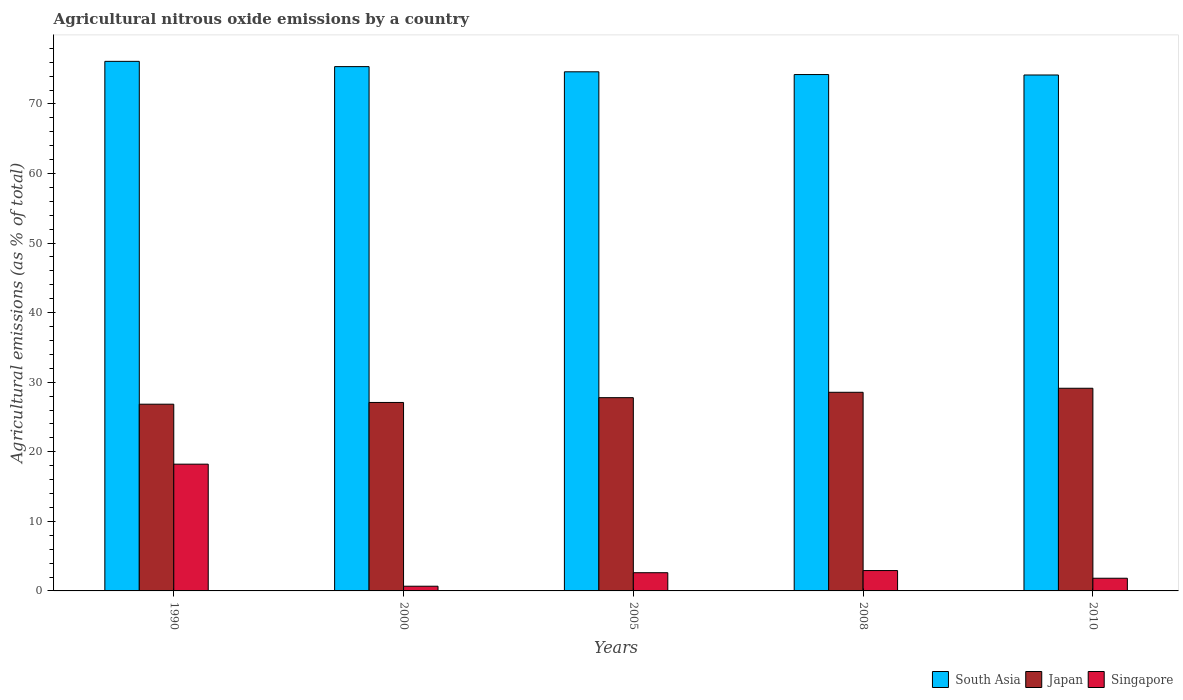How many different coloured bars are there?
Make the answer very short. 3. How many groups of bars are there?
Your response must be concise. 5. Are the number of bars per tick equal to the number of legend labels?
Offer a very short reply. Yes. Are the number of bars on each tick of the X-axis equal?
Your response must be concise. Yes. How many bars are there on the 3rd tick from the left?
Ensure brevity in your answer.  3. How many bars are there on the 4th tick from the right?
Keep it short and to the point. 3. What is the amount of agricultural nitrous oxide emitted in South Asia in 2005?
Make the answer very short. 74.62. Across all years, what is the maximum amount of agricultural nitrous oxide emitted in Singapore?
Offer a terse response. 18.22. Across all years, what is the minimum amount of agricultural nitrous oxide emitted in Japan?
Offer a terse response. 26.84. In which year was the amount of agricultural nitrous oxide emitted in Japan maximum?
Keep it short and to the point. 2010. What is the total amount of agricultural nitrous oxide emitted in Japan in the graph?
Ensure brevity in your answer.  139.39. What is the difference between the amount of agricultural nitrous oxide emitted in Singapore in 2005 and that in 2008?
Provide a short and direct response. -0.31. What is the difference between the amount of agricultural nitrous oxide emitted in Singapore in 2008 and the amount of agricultural nitrous oxide emitted in Japan in 2010?
Your answer should be very brief. -26.2. What is the average amount of agricultural nitrous oxide emitted in Japan per year?
Provide a succinct answer. 27.88. In the year 2008, what is the difference between the amount of agricultural nitrous oxide emitted in Japan and amount of agricultural nitrous oxide emitted in South Asia?
Your response must be concise. -45.67. In how many years, is the amount of agricultural nitrous oxide emitted in Japan greater than 56 %?
Offer a terse response. 0. What is the ratio of the amount of agricultural nitrous oxide emitted in Japan in 2000 to that in 2005?
Offer a terse response. 0.98. Is the difference between the amount of agricultural nitrous oxide emitted in Japan in 1990 and 2010 greater than the difference between the amount of agricultural nitrous oxide emitted in South Asia in 1990 and 2010?
Ensure brevity in your answer.  No. What is the difference between the highest and the second highest amount of agricultural nitrous oxide emitted in South Asia?
Your response must be concise. 0.76. What is the difference between the highest and the lowest amount of agricultural nitrous oxide emitted in Japan?
Offer a terse response. 2.29. Is the sum of the amount of agricultural nitrous oxide emitted in Japan in 1990 and 2005 greater than the maximum amount of agricultural nitrous oxide emitted in Singapore across all years?
Keep it short and to the point. Yes. What does the 3rd bar from the left in 1990 represents?
Your answer should be compact. Singapore. What does the 2nd bar from the right in 2010 represents?
Keep it short and to the point. Japan. Are the values on the major ticks of Y-axis written in scientific E-notation?
Your response must be concise. No. Where does the legend appear in the graph?
Offer a terse response. Bottom right. How many legend labels are there?
Ensure brevity in your answer.  3. What is the title of the graph?
Keep it short and to the point. Agricultural nitrous oxide emissions by a country. What is the label or title of the X-axis?
Provide a succinct answer. Years. What is the label or title of the Y-axis?
Provide a short and direct response. Agricultural emissions (as % of total). What is the Agricultural emissions (as % of total) of South Asia in 1990?
Provide a succinct answer. 76.12. What is the Agricultural emissions (as % of total) in Japan in 1990?
Ensure brevity in your answer.  26.84. What is the Agricultural emissions (as % of total) of Singapore in 1990?
Offer a terse response. 18.22. What is the Agricultural emissions (as % of total) in South Asia in 2000?
Your answer should be very brief. 75.36. What is the Agricultural emissions (as % of total) of Japan in 2000?
Give a very brief answer. 27.09. What is the Agricultural emissions (as % of total) in Singapore in 2000?
Provide a succinct answer. 0.67. What is the Agricultural emissions (as % of total) in South Asia in 2005?
Offer a terse response. 74.62. What is the Agricultural emissions (as % of total) of Japan in 2005?
Provide a succinct answer. 27.78. What is the Agricultural emissions (as % of total) of Singapore in 2005?
Your response must be concise. 2.62. What is the Agricultural emissions (as % of total) of South Asia in 2008?
Ensure brevity in your answer.  74.22. What is the Agricultural emissions (as % of total) in Japan in 2008?
Provide a succinct answer. 28.55. What is the Agricultural emissions (as % of total) of Singapore in 2008?
Offer a terse response. 2.93. What is the Agricultural emissions (as % of total) in South Asia in 2010?
Make the answer very short. 74.16. What is the Agricultural emissions (as % of total) in Japan in 2010?
Provide a short and direct response. 29.13. What is the Agricultural emissions (as % of total) of Singapore in 2010?
Your answer should be compact. 1.82. Across all years, what is the maximum Agricultural emissions (as % of total) in South Asia?
Provide a short and direct response. 76.12. Across all years, what is the maximum Agricultural emissions (as % of total) of Japan?
Offer a terse response. 29.13. Across all years, what is the maximum Agricultural emissions (as % of total) in Singapore?
Keep it short and to the point. 18.22. Across all years, what is the minimum Agricultural emissions (as % of total) of South Asia?
Make the answer very short. 74.16. Across all years, what is the minimum Agricultural emissions (as % of total) of Japan?
Offer a very short reply. 26.84. Across all years, what is the minimum Agricultural emissions (as % of total) of Singapore?
Offer a very short reply. 0.67. What is the total Agricultural emissions (as % of total) in South Asia in the graph?
Ensure brevity in your answer.  374.48. What is the total Agricultural emissions (as % of total) in Japan in the graph?
Provide a succinct answer. 139.39. What is the total Agricultural emissions (as % of total) of Singapore in the graph?
Ensure brevity in your answer.  26.26. What is the difference between the Agricultural emissions (as % of total) of South Asia in 1990 and that in 2000?
Make the answer very short. 0.76. What is the difference between the Agricultural emissions (as % of total) of Japan in 1990 and that in 2000?
Ensure brevity in your answer.  -0.25. What is the difference between the Agricultural emissions (as % of total) of Singapore in 1990 and that in 2000?
Offer a terse response. 17.55. What is the difference between the Agricultural emissions (as % of total) of South Asia in 1990 and that in 2005?
Offer a terse response. 1.5. What is the difference between the Agricultural emissions (as % of total) of Japan in 1990 and that in 2005?
Offer a terse response. -0.94. What is the difference between the Agricultural emissions (as % of total) of Singapore in 1990 and that in 2005?
Provide a short and direct response. 15.6. What is the difference between the Agricultural emissions (as % of total) in South Asia in 1990 and that in 2008?
Ensure brevity in your answer.  1.9. What is the difference between the Agricultural emissions (as % of total) in Japan in 1990 and that in 2008?
Ensure brevity in your answer.  -1.71. What is the difference between the Agricultural emissions (as % of total) in Singapore in 1990 and that in 2008?
Your answer should be compact. 15.29. What is the difference between the Agricultural emissions (as % of total) of South Asia in 1990 and that in 2010?
Offer a very short reply. 1.96. What is the difference between the Agricultural emissions (as % of total) of Japan in 1990 and that in 2010?
Make the answer very short. -2.29. What is the difference between the Agricultural emissions (as % of total) in Singapore in 1990 and that in 2010?
Provide a short and direct response. 16.4. What is the difference between the Agricultural emissions (as % of total) in South Asia in 2000 and that in 2005?
Provide a succinct answer. 0.75. What is the difference between the Agricultural emissions (as % of total) of Japan in 2000 and that in 2005?
Offer a very short reply. -0.69. What is the difference between the Agricultural emissions (as % of total) of Singapore in 2000 and that in 2005?
Your response must be concise. -1.94. What is the difference between the Agricultural emissions (as % of total) of South Asia in 2000 and that in 2008?
Offer a very short reply. 1.14. What is the difference between the Agricultural emissions (as % of total) of Japan in 2000 and that in 2008?
Keep it short and to the point. -1.46. What is the difference between the Agricultural emissions (as % of total) of Singapore in 2000 and that in 2008?
Ensure brevity in your answer.  -2.25. What is the difference between the Agricultural emissions (as % of total) of South Asia in 2000 and that in 2010?
Your answer should be very brief. 1.2. What is the difference between the Agricultural emissions (as % of total) of Japan in 2000 and that in 2010?
Your answer should be very brief. -2.04. What is the difference between the Agricultural emissions (as % of total) of Singapore in 2000 and that in 2010?
Offer a very short reply. -1.15. What is the difference between the Agricultural emissions (as % of total) in South Asia in 2005 and that in 2008?
Provide a succinct answer. 0.39. What is the difference between the Agricultural emissions (as % of total) in Japan in 2005 and that in 2008?
Provide a short and direct response. -0.77. What is the difference between the Agricultural emissions (as % of total) in Singapore in 2005 and that in 2008?
Keep it short and to the point. -0.31. What is the difference between the Agricultural emissions (as % of total) in South Asia in 2005 and that in 2010?
Offer a very short reply. 0.46. What is the difference between the Agricultural emissions (as % of total) of Japan in 2005 and that in 2010?
Make the answer very short. -1.35. What is the difference between the Agricultural emissions (as % of total) of Singapore in 2005 and that in 2010?
Make the answer very short. 0.79. What is the difference between the Agricultural emissions (as % of total) in South Asia in 2008 and that in 2010?
Your answer should be very brief. 0.06. What is the difference between the Agricultural emissions (as % of total) of Japan in 2008 and that in 2010?
Ensure brevity in your answer.  -0.58. What is the difference between the Agricultural emissions (as % of total) in Singapore in 2008 and that in 2010?
Offer a very short reply. 1.11. What is the difference between the Agricultural emissions (as % of total) in South Asia in 1990 and the Agricultural emissions (as % of total) in Japan in 2000?
Offer a very short reply. 49.03. What is the difference between the Agricultural emissions (as % of total) in South Asia in 1990 and the Agricultural emissions (as % of total) in Singapore in 2000?
Your response must be concise. 75.44. What is the difference between the Agricultural emissions (as % of total) in Japan in 1990 and the Agricultural emissions (as % of total) in Singapore in 2000?
Keep it short and to the point. 26.16. What is the difference between the Agricultural emissions (as % of total) in South Asia in 1990 and the Agricultural emissions (as % of total) in Japan in 2005?
Provide a short and direct response. 48.34. What is the difference between the Agricultural emissions (as % of total) in South Asia in 1990 and the Agricultural emissions (as % of total) in Singapore in 2005?
Offer a very short reply. 73.5. What is the difference between the Agricultural emissions (as % of total) of Japan in 1990 and the Agricultural emissions (as % of total) of Singapore in 2005?
Offer a very short reply. 24.22. What is the difference between the Agricultural emissions (as % of total) in South Asia in 1990 and the Agricultural emissions (as % of total) in Japan in 2008?
Offer a very short reply. 47.57. What is the difference between the Agricultural emissions (as % of total) in South Asia in 1990 and the Agricultural emissions (as % of total) in Singapore in 2008?
Your answer should be very brief. 73.19. What is the difference between the Agricultural emissions (as % of total) in Japan in 1990 and the Agricultural emissions (as % of total) in Singapore in 2008?
Ensure brevity in your answer.  23.91. What is the difference between the Agricultural emissions (as % of total) of South Asia in 1990 and the Agricultural emissions (as % of total) of Japan in 2010?
Provide a succinct answer. 46.99. What is the difference between the Agricultural emissions (as % of total) in South Asia in 1990 and the Agricultural emissions (as % of total) in Singapore in 2010?
Ensure brevity in your answer.  74.3. What is the difference between the Agricultural emissions (as % of total) in Japan in 1990 and the Agricultural emissions (as % of total) in Singapore in 2010?
Keep it short and to the point. 25.02. What is the difference between the Agricultural emissions (as % of total) of South Asia in 2000 and the Agricultural emissions (as % of total) of Japan in 2005?
Keep it short and to the point. 47.58. What is the difference between the Agricultural emissions (as % of total) of South Asia in 2000 and the Agricultural emissions (as % of total) of Singapore in 2005?
Keep it short and to the point. 72.75. What is the difference between the Agricultural emissions (as % of total) in Japan in 2000 and the Agricultural emissions (as % of total) in Singapore in 2005?
Make the answer very short. 24.47. What is the difference between the Agricultural emissions (as % of total) in South Asia in 2000 and the Agricultural emissions (as % of total) in Japan in 2008?
Give a very brief answer. 46.81. What is the difference between the Agricultural emissions (as % of total) in South Asia in 2000 and the Agricultural emissions (as % of total) in Singapore in 2008?
Keep it short and to the point. 72.43. What is the difference between the Agricultural emissions (as % of total) of Japan in 2000 and the Agricultural emissions (as % of total) of Singapore in 2008?
Keep it short and to the point. 24.16. What is the difference between the Agricultural emissions (as % of total) in South Asia in 2000 and the Agricultural emissions (as % of total) in Japan in 2010?
Give a very brief answer. 46.23. What is the difference between the Agricultural emissions (as % of total) of South Asia in 2000 and the Agricultural emissions (as % of total) of Singapore in 2010?
Provide a short and direct response. 73.54. What is the difference between the Agricultural emissions (as % of total) in Japan in 2000 and the Agricultural emissions (as % of total) in Singapore in 2010?
Make the answer very short. 25.27. What is the difference between the Agricultural emissions (as % of total) of South Asia in 2005 and the Agricultural emissions (as % of total) of Japan in 2008?
Offer a terse response. 46.06. What is the difference between the Agricultural emissions (as % of total) of South Asia in 2005 and the Agricultural emissions (as % of total) of Singapore in 2008?
Give a very brief answer. 71.69. What is the difference between the Agricultural emissions (as % of total) in Japan in 2005 and the Agricultural emissions (as % of total) in Singapore in 2008?
Make the answer very short. 24.85. What is the difference between the Agricultural emissions (as % of total) of South Asia in 2005 and the Agricultural emissions (as % of total) of Japan in 2010?
Your response must be concise. 45.49. What is the difference between the Agricultural emissions (as % of total) in South Asia in 2005 and the Agricultural emissions (as % of total) in Singapore in 2010?
Give a very brief answer. 72.79. What is the difference between the Agricultural emissions (as % of total) of Japan in 2005 and the Agricultural emissions (as % of total) of Singapore in 2010?
Offer a very short reply. 25.96. What is the difference between the Agricultural emissions (as % of total) in South Asia in 2008 and the Agricultural emissions (as % of total) in Japan in 2010?
Provide a short and direct response. 45.09. What is the difference between the Agricultural emissions (as % of total) in South Asia in 2008 and the Agricultural emissions (as % of total) in Singapore in 2010?
Offer a terse response. 72.4. What is the difference between the Agricultural emissions (as % of total) in Japan in 2008 and the Agricultural emissions (as % of total) in Singapore in 2010?
Give a very brief answer. 26.73. What is the average Agricultural emissions (as % of total) of South Asia per year?
Provide a succinct answer. 74.9. What is the average Agricultural emissions (as % of total) in Japan per year?
Provide a succinct answer. 27.88. What is the average Agricultural emissions (as % of total) of Singapore per year?
Offer a very short reply. 5.25. In the year 1990, what is the difference between the Agricultural emissions (as % of total) of South Asia and Agricultural emissions (as % of total) of Japan?
Give a very brief answer. 49.28. In the year 1990, what is the difference between the Agricultural emissions (as % of total) of South Asia and Agricultural emissions (as % of total) of Singapore?
Give a very brief answer. 57.9. In the year 1990, what is the difference between the Agricultural emissions (as % of total) of Japan and Agricultural emissions (as % of total) of Singapore?
Your answer should be compact. 8.62. In the year 2000, what is the difference between the Agricultural emissions (as % of total) of South Asia and Agricultural emissions (as % of total) of Japan?
Make the answer very short. 48.27. In the year 2000, what is the difference between the Agricultural emissions (as % of total) of South Asia and Agricultural emissions (as % of total) of Singapore?
Provide a short and direct response. 74.69. In the year 2000, what is the difference between the Agricultural emissions (as % of total) of Japan and Agricultural emissions (as % of total) of Singapore?
Give a very brief answer. 26.41. In the year 2005, what is the difference between the Agricultural emissions (as % of total) of South Asia and Agricultural emissions (as % of total) of Japan?
Offer a very short reply. 46.84. In the year 2005, what is the difference between the Agricultural emissions (as % of total) in South Asia and Agricultural emissions (as % of total) in Singapore?
Ensure brevity in your answer.  72. In the year 2005, what is the difference between the Agricultural emissions (as % of total) in Japan and Agricultural emissions (as % of total) in Singapore?
Provide a short and direct response. 25.16. In the year 2008, what is the difference between the Agricultural emissions (as % of total) of South Asia and Agricultural emissions (as % of total) of Japan?
Your answer should be very brief. 45.67. In the year 2008, what is the difference between the Agricultural emissions (as % of total) in South Asia and Agricultural emissions (as % of total) in Singapore?
Your response must be concise. 71.29. In the year 2008, what is the difference between the Agricultural emissions (as % of total) in Japan and Agricultural emissions (as % of total) in Singapore?
Ensure brevity in your answer.  25.62. In the year 2010, what is the difference between the Agricultural emissions (as % of total) of South Asia and Agricultural emissions (as % of total) of Japan?
Provide a succinct answer. 45.03. In the year 2010, what is the difference between the Agricultural emissions (as % of total) in South Asia and Agricultural emissions (as % of total) in Singapore?
Offer a very short reply. 72.34. In the year 2010, what is the difference between the Agricultural emissions (as % of total) of Japan and Agricultural emissions (as % of total) of Singapore?
Your response must be concise. 27.31. What is the ratio of the Agricultural emissions (as % of total) in Singapore in 1990 to that in 2000?
Your answer should be compact. 27.02. What is the ratio of the Agricultural emissions (as % of total) of South Asia in 1990 to that in 2005?
Offer a very short reply. 1.02. What is the ratio of the Agricultural emissions (as % of total) in Japan in 1990 to that in 2005?
Keep it short and to the point. 0.97. What is the ratio of the Agricultural emissions (as % of total) in Singapore in 1990 to that in 2005?
Ensure brevity in your answer.  6.96. What is the ratio of the Agricultural emissions (as % of total) of South Asia in 1990 to that in 2008?
Ensure brevity in your answer.  1.03. What is the ratio of the Agricultural emissions (as % of total) in Japan in 1990 to that in 2008?
Ensure brevity in your answer.  0.94. What is the ratio of the Agricultural emissions (as % of total) of Singapore in 1990 to that in 2008?
Make the answer very short. 6.22. What is the ratio of the Agricultural emissions (as % of total) in South Asia in 1990 to that in 2010?
Offer a very short reply. 1.03. What is the ratio of the Agricultural emissions (as % of total) of Japan in 1990 to that in 2010?
Your response must be concise. 0.92. What is the ratio of the Agricultural emissions (as % of total) in Singapore in 1990 to that in 2010?
Your answer should be very brief. 10. What is the ratio of the Agricultural emissions (as % of total) in Japan in 2000 to that in 2005?
Your answer should be compact. 0.98. What is the ratio of the Agricultural emissions (as % of total) in Singapore in 2000 to that in 2005?
Provide a short and direct response. 0.26. What is the ratio of the Agricultural emissions (as % of total) of South Asia in 2000 to that in 2008?
Ensure brevity in your answer.  1.02. What is the ratio of the Agricultural emissions (as % of total) of Japan in 2000 to that in 2008?
Offer a terse response. 0.95. What is the ratio of the Agricultural emissions (as % of total) of Singapore in 2000 to that in 2008?
Offer a terse response. 0.23. What is the ratio of the Agricultural emissions (as % of total) in South Asia in 2000 to that in 2010?
Keep it short and to the point. 1.02. What is the ratio of the Agricultural emissions (as % of total) of Japan in 2000 to that in 2010?
Provide a short and direct response. 0.93. What is the ratio of the Agricultural emissions (as % of total) of Singapore in 2000 to that in 2010?
Keep it short and to the point. 0.37. What is the ratio of the Agricultural emissions (as % of total) of Japan in 2005 to that in 2008?
Keep it short and to the point. 0.97. What is the ratio of the Agricultural emissions (as % of total) in Singapore in 2005 to that in 2008?
Provide a succinct answer. 0.89. What is the ratio of the Agricultural emissions (as % of total) of Japan in 2005 to that in 2010?
Offer a very short reply. 0.95. What is the ratio of the Agricultural emissions (as % of total) of Singapore in 2005 to that in 2010?
Your response must be concise. 1.44. What is the ratio of the Agricultural emissions (as % of total) in Japan in 2008 to that in 2010?
Ensure brevity in your answer.  0.98. What is the ratio of the Agricultural emissions (as % of total) of Singapore in 2008 to that in 2010?
Offer a terse response. 1.61. What is the difference between the highest and the second highest Agricultural emissions (as % of total) in South Asia?
Provide a succinct answer. 0.76. What is the difference between the highest and the second highest Agricultural emissions (as % of total) of Japan?
Give a very brief answer. 0.58. What is the difference between the highest and the second highest Agricultural emissions (as % of total) in Singapore?
Ensure brevity in your answer.  15.29. What is the difference between the highest and the lowest Agricultural emissions (as % of total) of South Asia?
Offer a very short reply. 1.96. What is the difference between the highest and the lowest Agricultural emissions (as % of total) in Japan?
Provide a succinct answer. 2.29. What is the difference between the highest and the lowest Agricultural emissions (as % of total) in Singapore?
Offer a very short reply. 17.55. 